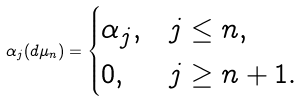Convert formula to latex. <formula><loc_0><loc_0><loc_500><loc_500>\alpha _ { j } ( d \mu _ { n } ) = \begin{cases} \alpha _ { j } , & j \leq n , \\ 0 , & j \geq n + 1 . \end{cases}</formula> 